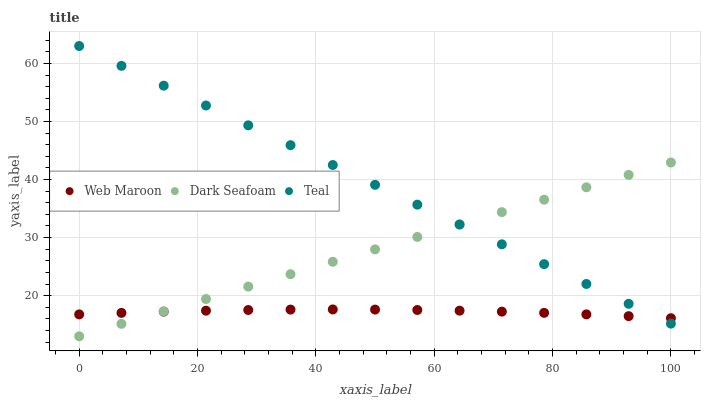Does Web Maroon have the minimum area under the curve?
Answer yes or no. Yes. Does Teal have the maximum area under the curve?
Answer yes or no. Yes. Does Teal have the minimum area under the curve?
Answer yes or no. No. Does Web Maroon have the maximum area under the curve?
Answer yes or no. No. Is Dark Seafoam the smoothest?
Answer yes or no. Yes. Is Web Maroon the roughest?
Answer yes or no. Yes. Is Teal the smoothest?
Answer yes or no. No. Is Teal the roughest?
Answer yes or no. No. Does Dark Seafoam have the lowest value?
Answer yes or no. Yes. Does Teal have the lowest value?
Answer yes or no. No. Does Teal have the highest value?
Answer yes or no. Yes. Does Web Maroon have the highest value?
Answer yes or no. No. Does Dark Seafoam intersect Web Maroon?
Answer yes or no. Yes. Is Dark Seafoam less than Web Maroon?
Answer yes or no. No. Is Dark Seafoam greater than Web Maroon?
Answer yes or no. No. 